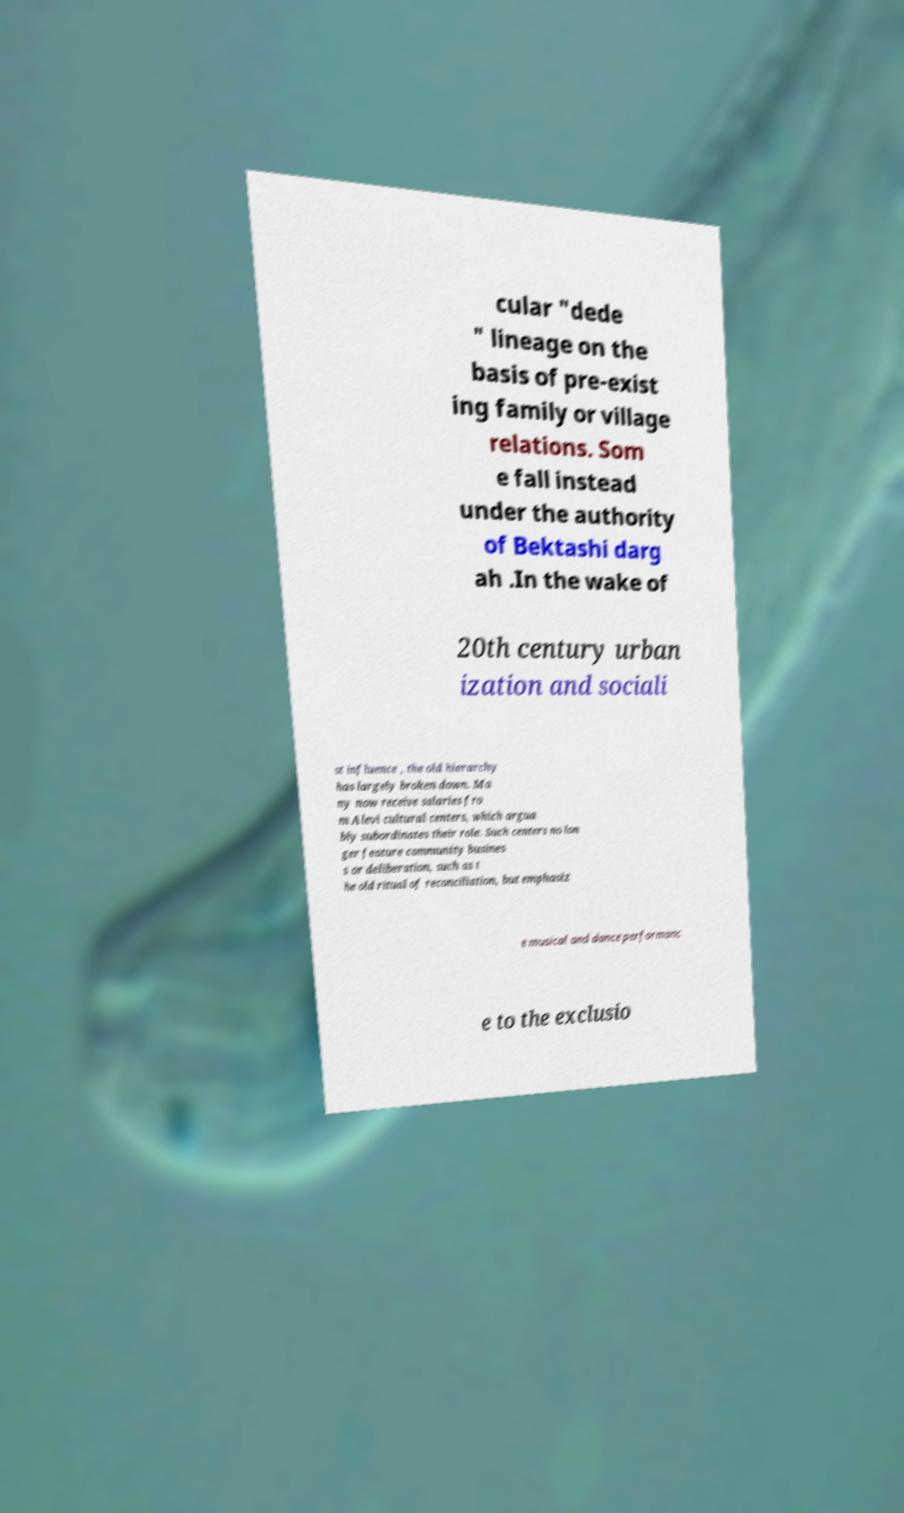For documentation purposes, I need the text within this image transcribed. Could you provide that? cular "dede " lineage on the basis of pre-exist ing family or village relations. Som e fall instead under the authority of Bektashi darg ah .In the wake of 20th century urban ization and sociali st influence , the old hierarchy has largely broken down. Ma ny now receive salaries fro m Alevi cultural centers, which argua bly subordinates their role. Such centers no lon ger feature community busines s or deliberation, such as t he old ritual of reconciliation, but emphasiz e musical and dance performanc e to the exclusio 